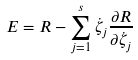<formula> <loc_0><loc_0><loc_500><loc_500>E = R - \sum _ { j = 1 } ^ { s } \dot { \zeta } _ { j } \frac { \partial R } { \partial \dot { \zeta } _ { j } }</formula> 